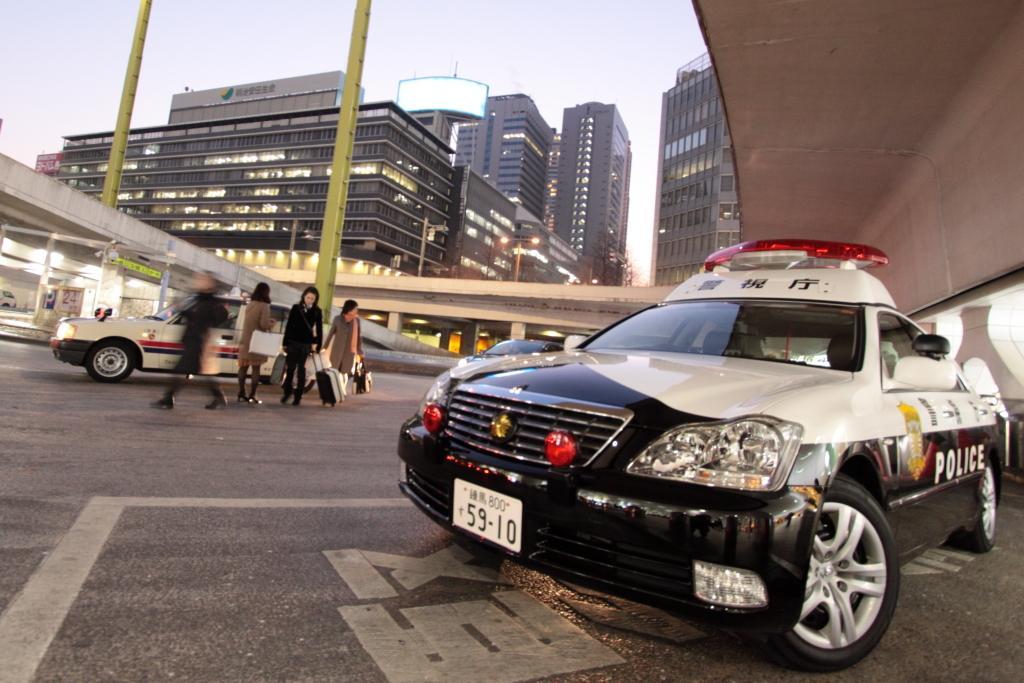In one or two sentences, can you explain what this image depicts? In this image I can see a car which is white, black and red in color is on the road. I can see few persons standing on the road, a car which is white in color on the road, few bridges, few lights and few buildings. In the background I can see the sky. 